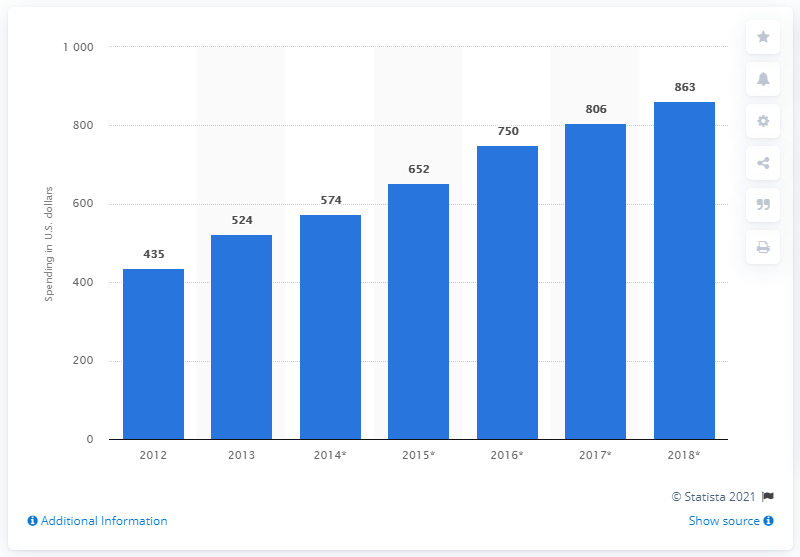Point out several critical features in this image. The projected growth of m-commerce spending per mobile buyer in 2018 is expected to be approximately 863. In 2013, the average amount of U.S. dollars spent on mobile commerce per mobile buyer was 524. 